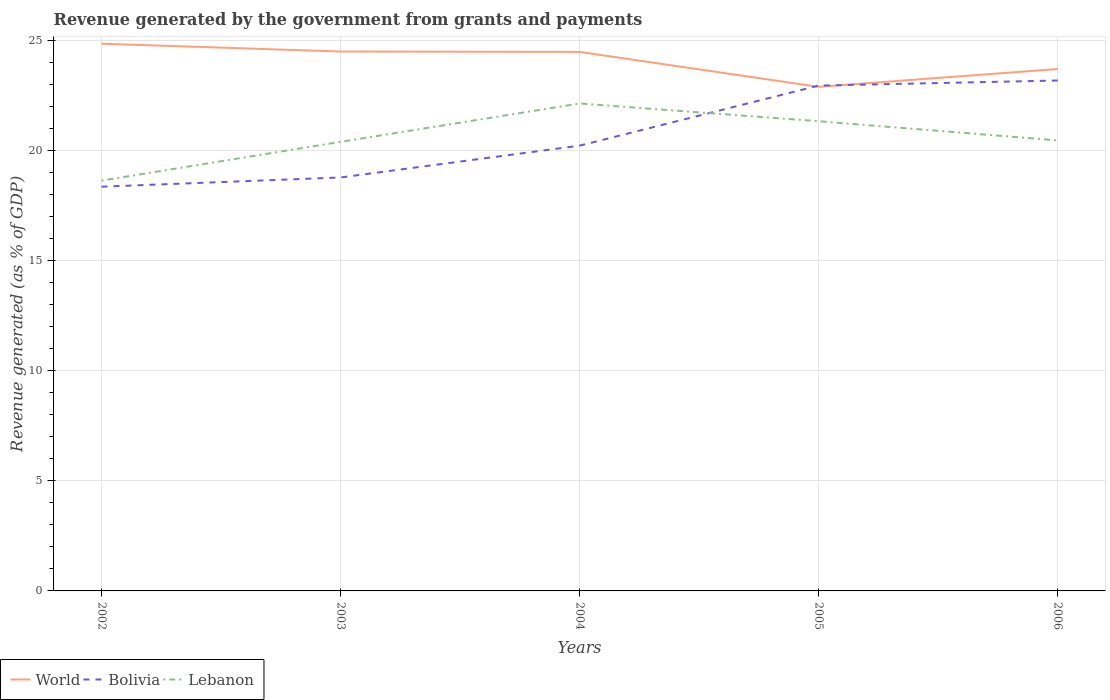How many different coloured lines are there?
Make the answer very short. 3. Does the line corresponding to Bolivia intersect with the line corresponding to World?
Make the answer very short. Yes. Across all years, what is the maximum revenue generated by the government in Bolivia?
Ensure brevity in your answer.  18.38. What is the total revenue generated by the government in World in the graph?
Ensure brevity in your answer.  1.15. What is the difference between the highest and the second highest revenue generated by the government in Lebanon?
Ensure brevity in your answer.  3.51. How many years are there in the graph?
Ensure brevity in your answer.  5. Are the values on the major ticks of Y-axis written in scientific E-notation?
Your answer should be very brief. No. Does the graph contain any zero values?
Keep it short and to the point. No. Does the graph contain grids?
Ensure brevity in your answer.  Yes. How are the legend labels stacked?
Offer a very short reply. Horizontal. What is the title of the graph?
Keep it short and to the point. Revenue generated by the government from grants and payments. What is the label or title of the X-axis?
Keep it short and to the point. Years. What is the label or title of the Y-axis?
Your response must be concise. Revenue generated (as % of GDP). What is the Revenue generated (as % of GDP) in World in 2002?
Offer a terse response. 24.88. What is the Revenue generated (as % of GDP) of Bolivia in 2002?
Offer a very short reply. 18.38. What is the Revenue generated (as % of GDP) of Lebanon in 2002?
Give a very brief answer. 18.65. What is the Revenue generated (as % of GDP) in World in 2003?
Offer a terse response. 24.52. What is the Revenue generated (as % of GDP) in Bolivia in 2003?
Offer a very short reply. 18.8. What is the Revenue generated (as % of GDP) of Lebanon in 2003?
Provide a short and direct response. 20.41. What is the Revenue generated (as % of GDP) in World in 2004?
Provide a short and direct response. 24.5. What is the Revenue generated (as % of GDP) of Bolivia in 2004?
Give a very brief answer. 20.24. What is the Revenue generated (as % of GDP) in Lebanon in 2004?
Offer a terse response. 22.16. What is the Revenue generated (as % of GDP) of World in 2005?
Keep it short and to the point. 22.92. What is the Revenue generated (as % of GDP) in Bolivia in 2005?
Keep it short and to the point. 22.97. What is the Revenue generated (as % of GDP) in Lebanon in 2005?
Your answer should be compact. 21.35. What is the Revenue generated (as % of GDP) in World in 2006?
Keep it short and to the point. 23.73. What is the Revenue generated (as % of GDP) in Bolivia in 2006?
Provide a short and direct response. 23.2. What is the Revenue generated (as % of GDP) of Lebanon in 2006?
Make the answer very short. 20.48. Across all years, what is the maximum Revenue generated (as % of GDP) of World?
Give a very brief answer. 24.88. Across all years, what is the maximum Revenue generated (as % of GDP) of Bolivia?
Make the answer very short. 23.2. Across all years, what is the maximum Revenue generated (as % of GDP) of Lebanon?
Ensure brevity in your answer.  22.16. Across all years, what is the minimum Revenue generated (as % of GDP) in World?
Keep it short and to the point. 22.92. Across all years, what is the minimum Revenue generated (as % of GDP) of Bolivia?
Keep it short and to the point. 18.38. Across all years, what is the minimum Revenue generated (as % of GDP) in Lebanon?
Your answer should be very brief. 18.65. What is the total Revenue generated (as % of GDP) in World in the graph?
Your response must be concise. 120.54. What is the total Revenue generated (as % of GDP) in Bolivia in the graph?
Offer a very short reply. 103.59. What is the total Revenue generated (as % of GDP) in Lebanon in the graph?
Make the answer very short. 103.06. What is the difference between the Revenue generated (as % of GDP) of World in 2002 and that in 2003?
Your answer should be compact. 0.35. What is the difference between the Revenue generated (as % of GDP) of Bolivia in 2002 and that in 2003?
Your answer should be compact. -0.42. What is the difference between the Revenue generated (as % of GDP) in Lebanon in 2002 and that in 2003?
Make the answer very short. -1.76. What is the difference between the Revenue generated (as % of GDP) of World in 2002 and that in 2004?
Ensure brevity in your answer.  0.37. What is the difference between the Revenue generated (as % of GDP) in Bolivia in 2002 and that in 2004?
Offer a very short reply. -1.87. What is the difference between the Revenue generated (as % of GDP) in Lebanon in 2002 and that in 2004?
Ensure brevity in your answer.  -3.51. What is the difference between the Revenue generated (as % of GDP) of World in 2002 and that in 2005?
Provide a succinct answer. 1.96. What is the difference between the Revenue generated (as % of GDP) of Bolivia in 2002 and that in 2005?
Ensure brevity in your answer.  -4.6. What is the difference between the Revenue generated (as % of GDP) of Lebanon in 2002 and that in 2005?
Offer a terse response. -2.7. What is the difference between the Revenue generated (as % of GDP) in World in 2002 and that in 2006?
Provide a short and direct response. 1.15. What is the difference between the Revenue generated (as % of GDP) in Bolivia in 2002 and that in 2006?
Offer a terse response. -4.83. What is the difference between the Revenue generated (as % of GDP) in Lebanon in 2002 and that in 2006?
Ensure brevity in your answer.  -1.83. What is the difference between the Revenue generated (as % of GDP) of World in 2003 and that in 2004?
Make the answer very short. 0.02. What is the difference between the Revenue generated (as % of GDP) of Bolivia in 2003 and that in 2004?
Make the answer very short. -1.45. What is the difference between the Revenue generated (as % of GDP) of Lebanon in 2003 and that in 2004?
Keep it short and to the point. -1.74. What is the difference between the Revenue generated (as % of GDP) of World in 2003 and that in 2005?
Provide a succinct answer. 1.61. What is the difference between the Revenue generated (as % of GDP) in Bolivia in 2003 and that in 2005?
Make the answer very short. -4.18. What is the difference between the Revenue generated (as % of GDP) in Lebanon in 2003 and that in 2005?
Your answer should be very brief. -0.94. What is the difference between the Revenue generated (as % of GDP) in World in 2003 and that in 2006?
Your response must be concise. 0.8. What is the difference between the Revenue generated (as % of GDP) of Bolivia in 2003 and that in 2006?
Provide a short and direct response. -4.41. What is the difference between the Revenue generated (as % of GDP) of Lebanon in 2003 and that in 2006?
Keep it short and to the point. -0.07. What is the difference between the Revenue generated (as % of GDP) in World in 2004 and that in 2005?
Offer a terse response. 1.59. What is the difference between the Revenue generated (as % of GDP) of Bolivia in 2004 and that in 2005?
Keep it short and to the point. -2.73. What is the difference between the Revenue generated (as % of GDP) of Lebanon in 2004 and that in 2005?
Provide a succinct answer. 0.81. What is the difference between the Revenue generated (as % of GDP) in World in 2004 and that in 2006?
Offer a very short reply. 0.78. What is the difference between the Revenue generated (as % of GDP) in Bolivia in 2004 and that in 2006?
Your answer should be very brief. -2.96. What is the difference between the Revenue generated (as % of GDP) in Lebanon in 2004 and that in 2006?
Offer a terse response. 1.68. What is the difference between the Revenue generated (as % of GDP) of World in 2005 and that in 2006?
Your answer should be very brief. -0.81. What is the difference between the Revenue generated (as % of GDP) in Bolivia in 2005 and that in 2006?
Make the answer very short. -0.23. What is the difference between the Revenue generated (as % of GDP) in Lebanon in 2005 and that in 2006?
Make the answer very short. 0.87. What is the difference between the Revenue generated (as % of GDP) of World in 2002 and the Revenue generated (as % of GDP) of Bolivia in 2003?
Give a very brief answer. 6.08. What is the difference between the Revenue generated (as % of GDP) in World in 2002 and the Revenue generated (as % of GDP) in Lebanon in 2003?
Provide a succinct answer. 4.46. What is the difference between the Revenue generated (as % of GDP) of Bolivia in 2002 and the Revenue generated (as % of GDP) of Lebanon in 2003?
Provide a short and direct response. -2.04. What is the difference between the Revenue generated (as % of GDP) in World in 2002 and the Revenue generated (as % of GDP) in Bolivia in 2004?
Keep it short and to the point. 4.63. What is the difference between the Revenue generated (as % of GDP) in World in 2002 and the Revenue generated (as % of GDP) in Lebanon in 2004?
Your answer should be compact. 2.72. What is the difference between the Revenue generated (as % of GDP) of Bolivia in 2002 and the Revenue generated (as % of GDP) of Lebanon in 2004?
Keep it short and to the point. -3.78. What is the difference between the Revenue generated (as % of GDP) of World in 2002 and the Revenue generated (as % of GDP) of Bolivia in 2005?
Make the answer very short. 1.9. What is the difference between the Revenue generated (as % of GDP) in World in 2002 and the Revenue generated (as % of GDP) in Lebanon in 2005?
Keep it short and to the point. 3.52. What is the difference between the Revenue generated (as % of GDP) in Bolivia in 2002 and the Revenue generated (as % of GDP) in Lebanon in 2005?
Your answer should be compact. -2.98. What is the difference between the Revenue generated (as % of GDP) in World in 2002 and the Revenue generated (as % of GDP) in Bolivia in 2006?
Give a very brief answer. 1.67. What is the difference between the Revenue generated (as % of GDP) in World in 2002 and the Revenue generated (as % of GDP) in Lebanon in 2006?
Provide a short and direct response. 4.4. What is the difference between the Revenue generated (as % of GDP) in Bolivia in 2002 and the Revenue generated (as % of GDP) in Lebanon in 2006?
Your answer should be compact. -2.1. What is the difference between the Revenue generated (as % of GDP) in World in 2003 and the Revenue generated (as % of GDP) in Bolivia in 2004?
Ensure brevity in your answer.  4.28. What is the difference between the Revenue generated (as % of GDP) of World in 2003 and the Revenue generated (as % of GDP) of Lebanon in 2004?
Your answer should be very brief. 2.36. What is the difference between the Revenue generated (as % of GDP) in Bolivia in 2003 and the Revenue generated (as % of GDP) in Lebanon in 2004?
Give a very brief answer. -3.36. What is the difference between the Revenue generated (as % of GDP) in World in 2003 and the Revenue generated (as % of GDP) in Bolivia in 2005?
Keep it short and to the point. 1.55. What is the difference between the Revenue generated (as % of GDP) of World in 2003 and the Revenue generated (as % of GDP) of Lebanon in 2005?
Offer a terse response. 3.17. What is the difference between the Revenue generated (as % of GDP) in Bolivia in 2003 and the Revenue generated (as % of GDP) in Lebanon in 2005?
Your response must be concise. -2.56. What is the difference between the Revenue generated (as % of GDP) of World in 2003 and the Revenue generated (as % of GDP) of Bolivia in 2006?
Give a very brief answer. 1.32. What is the difference between the Revenue generated (as % of GDP) in World in 2003 and the Revenue generated (as % of GDP) in Lebanon in 2006?
Provide a succinct answer. 4.04. What is the difference between the Revenue generated (as % of GDP) of Bolivia in 2003 and the Revenue generated (as % of GDP) of Lebanon in 2006?
Offer a very short reply. -1.69. What is the difference between the Revenue generated (as % of GDP) of World in 2004 and the Revenue generated (as % of GDP) of Bolivia in 2005?
Your answer should be compact. 1.53. What is the difference between the Revenue generated (as % of GDP) of World in 2004 and the Revenue generated (as % of GDP) of Lebanon in 2005?
Provide a succinct answer. 3.15. What is the difference between the Revenue generated (as % of GDP) in Bolivia in 2004 and the Revenue generated (as % of GDP) in Lebanon in 2005?
Ensure brevity in your answer.  -1.11. What is the difference between the Revenue generated (as % of GDP) in World in 2004 and the Revenue generated (as % of GDP) in Bolivia in 2006?
Your answer should be compact. 1.3. What is the difference between the Revenue generated (as % of GDP) in World in 2004 and the Revenue generated (as % of GDP) in Lebanon in 2006?
Your response must be concise. 4.02. What is the difference between the Revenue generated (as % of GDP) in Bolivia in 2004 and the Revenue generated (as % of GDP) in Lebanon in 2006?
Offer a terse response. -0.24. What is the difference between the Revenue generated (as % of GDP) in World in 2005 and the Revenue generated (as % of GDP) in Bolivia in 2006?
Offer a terse response. -0.29. What is the difference between the Revenue generated (as % of GDP) in World in 2005 and the Revenue generated (as % of GDP) in Lebanon in 2006?
Offer a very short reply. 2.43. What is the difference between the Revenue generated (as % of GDP) in Bolivia in 2005 and the Revenue generated (as % of GDP) in Lebanon in 2006?
Make the answer very short. 2.49. What is the average Revenue generated (as % of GDP) in World per year?
Ensure brevity in your answer.  24.11. What is the average Revenue generated (as % of GDP) in Bolivia per year?
Your response must be concise. 20.72. What is the average Revenue generated (as % of GDP) in Lebanon per year?
Provide a short and direct response. 20.61. In the year 2002, what is the difference between the Revenue generated (as % of GDP) of World and Revenue generated (as % of GDP) of Bolivia?
Keep it short and to the point. 6.5. In the year 2002, what is the difference between the Revenue generated (as % of GDP) of World and Revenue generated (as % of GDP) of Lebanon?
Provide a succinct answer. 6.22. In the year 2002, what is the difference between the Revenue generated (as % of GDP) in Bolivia and Revenue generated (as % of GDP) in Lebanon?
Give a very brief answer. -0.28. In the year 2003, what is the difference between the Revenue generated (as % of GDP) of World and Revenue generated (as % of GDP) of Bolivia?
Ensure brevity in your answer.  5.73. In the year 2003, what is the difference between the Revenue generated (as % of GDP) of World and Revenue generated (as % of GDP) of Lebanon?
Provide a succinct answer. 4.11. In the year 2003, what is the difference between the Revenue generated (as % of GDP) in Bolivia and Revenue generated (as % of GDP) in Lebanon?
Offer a very short reply. -1.62. In the year 2004, what is the difference between the Revenue generated (as % of GDP) in World and Revenue generated (as % of GDP) in Bolivia?
Provide a short and direct response. 4.26. In the year 2004, what is the difference between the Revenue generated (as % of GDP) in World and Revenue generated (as % of GDP) in Lebanon?
Make the answer very short. 2.35. In the year 2004, what is the difference between the Revenue generated (as % of GDP) of Bolivia and Revenue generated (as % of GDP) of Lebanon?
Ensure brevity in your answer.  -1.92. In the year 2005, what is the difference between the Revenue generated (as % of GDP) in World and Revenue generated (as % of GDP) in Bolivia?
Your response must be concise. -0.06. In the year 2005, what is the difference between the Revenue generated (as % of GDP) of World and Revenue generated (as % of GDP) of Lebanon?
Your answer should be very brief. 1.56. In the year 2005, what is the difference between the Revenue generated (as % of GDP) of Bolivia and Revenue generated (as % of GDP) of Lebanon?
Provide a succinct answer. 1.62. In the year 2006, what is the difference between the Revenue generated (as % of GDP) of World and Revenue generated (as % of GDP) of Bolivia?
Give a very brief answer. 0.52. In the year 2006, what is the difference between the Revenue generated (as % of GDP) of World and Revenue generated (as % of GDP) of Lebanon?
Offer a very short reply. 3.25. In the year 2006, what is the difference between the Revenue generated (as % of GDP) in Bolivia and Revenue generated (as % of GDP) in Lebanon?
Offer a very short reply. 2.72. What is the ratio of the Revenue generated (as % of GDP) in World in 2002 to that in 2003?
Ensure brevity in your answer.  1.01. What is the ratio of the Revenue generated (as % of GDP) of Bolivia in 2002 to that in 2003?
Provide a short and direct response. 0.98. What is the ratio of the Revenue generated (as % of GDP) of Lebanon in 2002 to that in 2003?
Make the answer very short. 0.91. What is the ratio of the Revenue generated (as % of GDP) in World in 2002 to that in 2004?
Offer a terse response. 1.02. What is the ratio of the Revenue generated (as % of GDP) in Bolivia in 2002 to that in 2004?
Give a very brief answer. 0.91. What is the ratio of the Revenue generated (as % of GDP) in Lebanon in 2002 to that in 2004?
Offer a terse response. 0.84. What is the ratio of the Revenue generated (as % of GDP) in World in 2002 to that in 2005?
Make the answer very short. 1.09. What is the ratio of the Revenue generated (as % of GDP) in Lebanon in 2002 to that in 2005?
Your answer should be compact. 0.87. What is the ratio of the Revenue generated (as % of GDP) of World in 2002 to that in 2006?
Provide a short and direct response. 1.05. What is the ratio of the Revenue generated (as % of GDP) of Bolivia in 2002 to that in 2006?
Your response must be concise. 0.79. What is the ratio of the Revenue generated (as % of GDP) of Lebanon in 2002 to that in 2006?
Provide a short and direct response. 0.91. What is the ratio of the Revenue generated (as % of GDP) of Bolivia in 2003 to that in 2004?
Offer a terse response. 0.93. What is the ratio of the Revenue generated (as % of GDP) of Lebanon in 2003 to that in 2004?
Your response must be concise. 0.92. What is the ratio of the Revenue generated (as % of GDP) in World in 2003 to that in 2005?
Your answer should be very brief. 1.07. What is the ratio of the Revenue generated (as % of GDP) in Bolivia in 2003 to that in 2005?
Give a very brief answer. 0.82. What is the ratio of the Revenue generated (as % of GDP) of Lebanon in 2003 to that in 2005?
Your response must be concise. 0.96. What is the ratio of the Revenue generated (as % of GDP) of World in 2003 to that in 2006?
Give a very brief answer. 1.03. What is the ratio of the Revenue generated (as % of GDP) of Bolivia in 2003 to that in 2006?
Give a very brief answer. 0.81. What is the ratio of the Revenue generated (as % of GDP) in World in 2004 to that in 2005?
Your answer should be very brief. 1.07. What is the ratio of the Revenue generated (as % of GDP) in Bolivia in 2004 to that in 2005?
Offer a terse response. 0.88. What is the ratio of the Revenue generated (as % of GDP) in Lebanon in 2004 to that in 2005?
Make the answer very short. 1.04. What is the ratio of the Revenue generated (as % of GDP) of World in 2004 to that in 2006?
Ensure brevity in your answer.  1.03. What is the ratio of the Revenue generated (as % of GDP) of Bolivia in 2004 to that in 2006?
Provide a succinct answer. 0.87. What is the ratio of the Revenue generated (as % of GDP) in Lebanon in 2004 to that in 2006?
Provide a succinct answer. 1.08. What is the ratio of the Revenue generated (as % of GDP) in World in 2005 to that in 2006?
Your answer should be very brief. 0.97. What is the ratio of the Revenue generated (as % of GDP) in Lebanon in 2005 to that in 2006?
Your response must be concise. 1.04. What is the difference between the highest and the second highest Revenue generated (as % of GDP) of World?
Your answer should be very brief. 0.35. What is the difference between the highest and the second highest Revenue generated (as % of GDP) of Bolivia?
Provide a succinct answer. 0.23. What is the difference between the highest and the second highest Revenue generated (as % of GDP) of Lebanon?
Make the answer very short. 0.81. What is the difference between the highest and the lowest Revenue generated (as % of GDP) in World?
Your answer should be very brief. 1.96. What is the difference between the highest and the lowest Revenue generated (as % of GDP) in Bolivia?
Ensure brevity in your answer.  4.83. What is the difference between the highest and the lowest Revenue generated (as % of GDP) of Lebanon?
Make the answer very short. 3.51. 